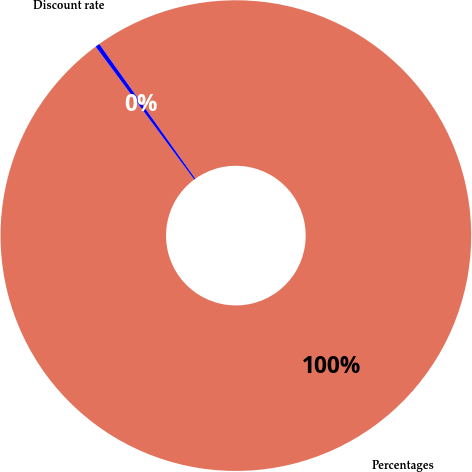<chart> <loc_0><loc_0><loc_500><loc_500><pie_chart><fcel>Percentages<fcel>Discount rate<nl><fcel>99.7%<fcel>0.3%<nl></chart> 